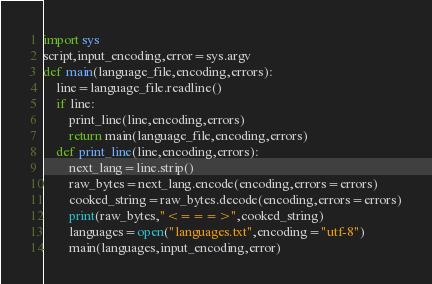Convert code to text. <code><loc_0><loc_0><loc_500><loc_500><_Python_>import sys
script,input_encoding,error=sys.argv
def main(language_file,encoding,errors):
    line=language_file.readline()
    if line:
        print_line(line,encoding,errors)
        return main(language_file,encoding,errors)
    def print_line(line,encoding,errors):
        next_lang=line.strip()
        raw_bytes=next_lang.encode(encoding,errors=errors)
        cooked_string=raw_bytes.decode(encoding,errors=errors)
        print(raw_bytes,"<===>",cooked_string)
        languages=open("languages.txt",encoding="utf-8")
        main(languages,input_encoding,error)
</code> 